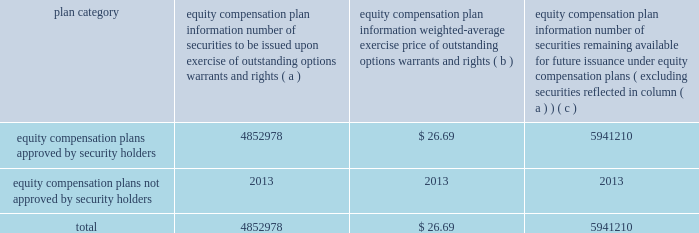Page 92 of 98 other information required by item 10 appearing under the caption 201cdirector nominees and continuing directors 201d and 201csection 16 ( a ) beneficial ownership reporting compliance , 201d of the company 2019s proxy statement to be filed pursuant to regulation 14a within 120 days after december 31 , 2006 , is incorporated herein by reference .
Item 11 .
Executive compensation the information required by item 11 appearing under the caption 201cexecutive compensation 201d in the company 2019s proxy statement , to be filed pursuant to regulation 14a within 120 days after december 31 , 2006 , is incorporated herein by reference .
Additionally , the ball corporation 2000 deferred compensation company stock plan , the ball corporation deposit share program and the ball corporation directors deposit share program were created to encourage key executives and other participants to acquire a larger equity ownership interest in the company and to increase their interest in the company 2019s stock performance .
Non-employee directors also participate in the 2000 deferred compensation company stock plan .
Item 12 .
Security ownership of certain beneficial owners and management the information required by item 12 appearing under the caption 201cvoting securities and principal shareholders , 201d in the company 2019s proxy statement to be filed pursuant to regulation 14a within 120 days after december 31 , 2006 , is incorporated herein by reference .
Securities authorized for issuance under equity compensation plans are summarized below: .
Item 13 .
Certain relationships and related transactions the information required by item 13 appearing under the caption 201cratification of the appointment of independent registered public accounting firm , 201d in the company 2019s proxy statement to be filed pursuant to regulation 14a within 120 days after december 31 , 2006 , is incorporated herein by reference .
Item 14 .
Principal accountant fees and services the information required by item 14 appearing under the caption 201ccertain committees of the board , 201d in the company 2019s proxy statement to be filed pursuant to regulation 14a within 120 days after december 31 , 2006 , is incorporated herein by reference. .
In the equity plans for 2006 , are there more shares issued than remaining in the plan? 
Computations: (5941210 > 4852978)
Answer: yes. 